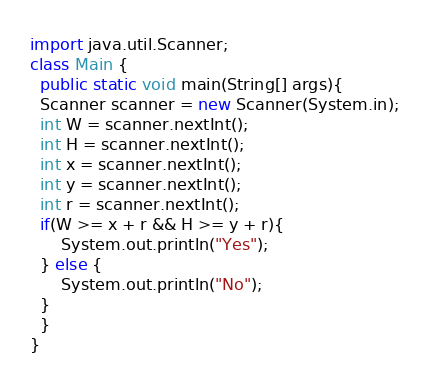<code> <loc_0><loc_0><loc_500><loc_500><_Java_>import java.util.Scanner;
class Main {
  public static void main(String[] args){
  Scanner scanner = new Scanner(System.in);
  int W = scanner.nextInt();
  int H = scanner.nextInt();
  int x = scanner.nextInt();
  int y = scanner.nextInt();
  int r = scanner.nextInt();
  if(W >= x + r && H >= y + r){
      System.out.println("Yes");
  } else {
      System.out.println("No");
  }
  }
}</code> 